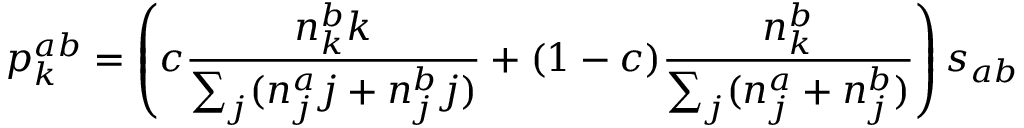<formula> <loc_0><loc_0><loc_500><loc_500>p _ { k } ^ { a b } = \left ( c \frac { n _ { k } ^ { b } k } { \sum _ { j } ( n _ { j } ^ { a } j + n _ { j } ^ { b } j ) } + ( 1 - c ) \frac { n _ { k } ^ { b } } { \sum _ { j } ( n _ { j } ^ { a } + n _ { j } ^ { b } ) } \right ) s _ { a b }</formula> 